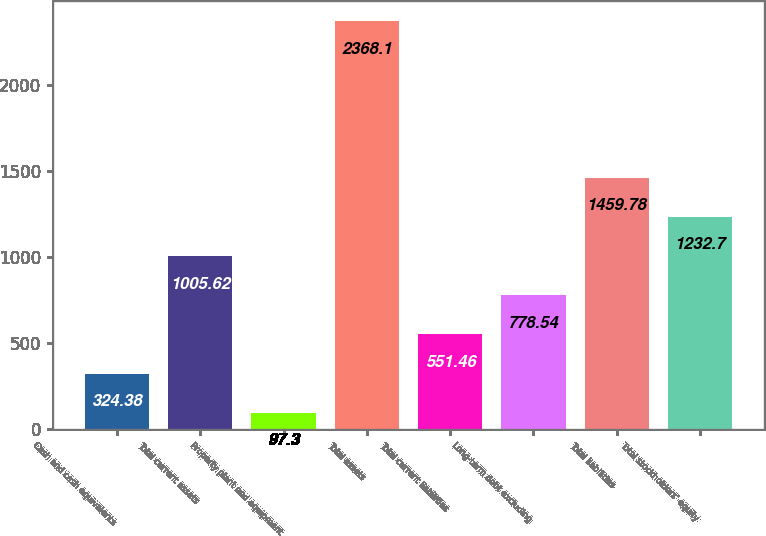Convert chart to OTSL. <chart><loc_0><loc_0><loc_500><loc_500><bar_chart><fcel>Cash and cash equivalents<fcel>Total current assets<fcel>Property plant and equipment<fcel>Total assets<fcel>Total current liabilities<fcel>Long-term debt excluding<fcel>Total liabilities<fcel>Total stockholders' equity<nl><fcel>324.38<fcel>1005.62<fcel>97.3<fcel>2368.1<fcel>551.46<fcel>778.54<fcel>1459.78<fcel>1232.7<nl></chart> 